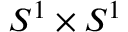Convert formula to latex. <formula><loc_0><loc_0><loc_500><loc_500>S ^ { 1 } \times S ^ { 1 }</formula> 